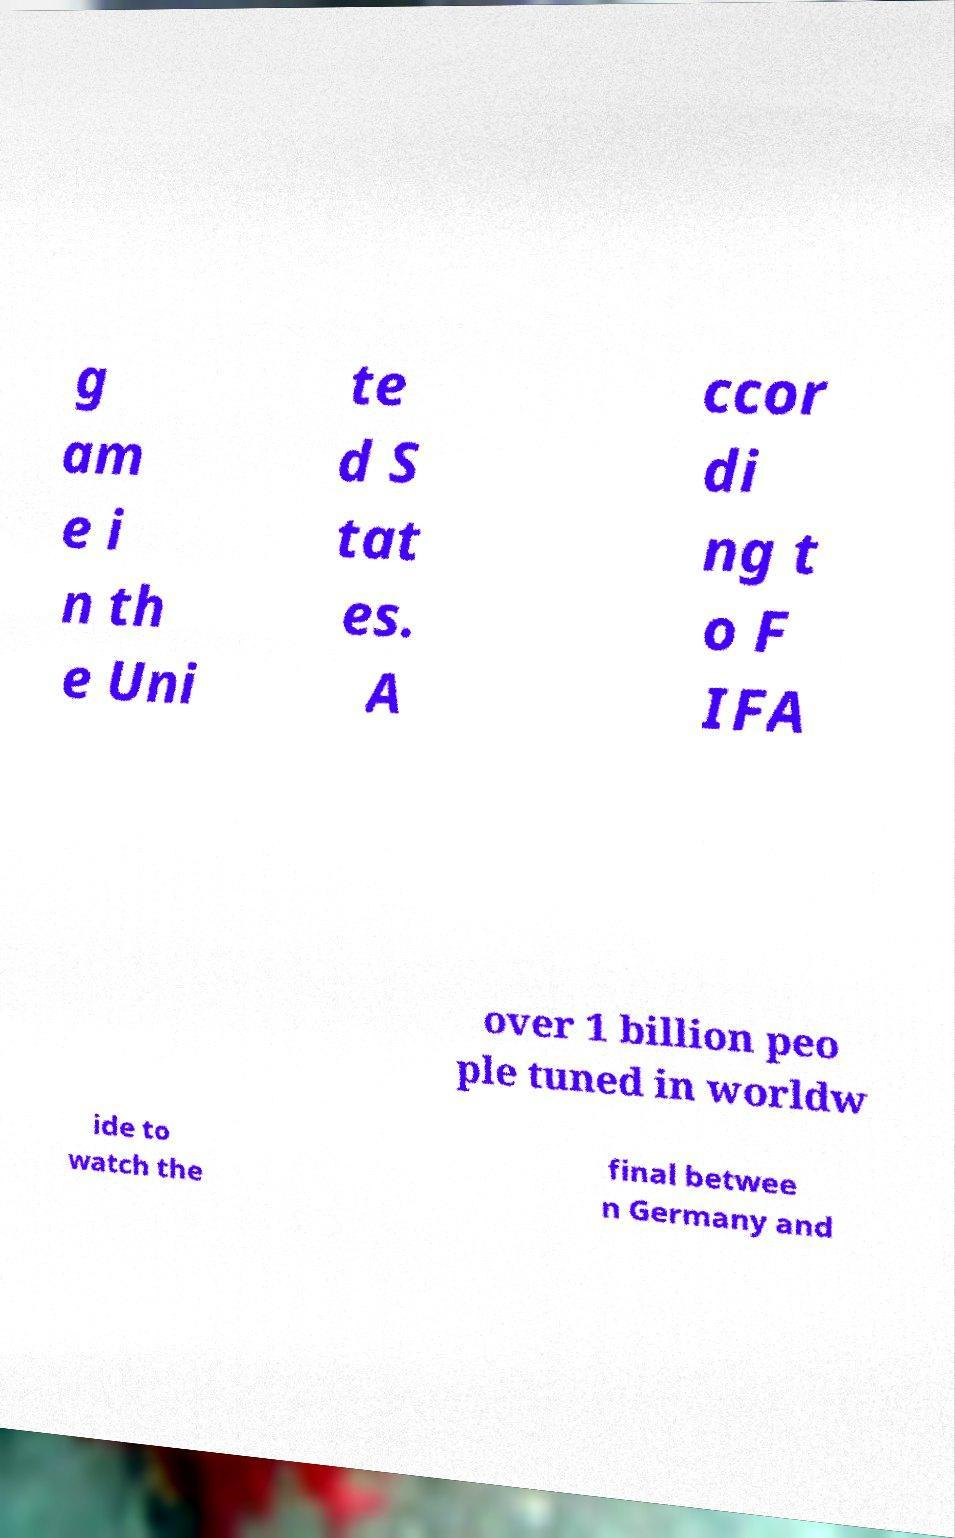Can you accurately transcribe the text from the provided image for me? g am e i n th e Uni te d S tat es. A ccor di ng t o F IFA over 1 billion peo ple tuned in worldw ide to watch the final betwee n Germany and 